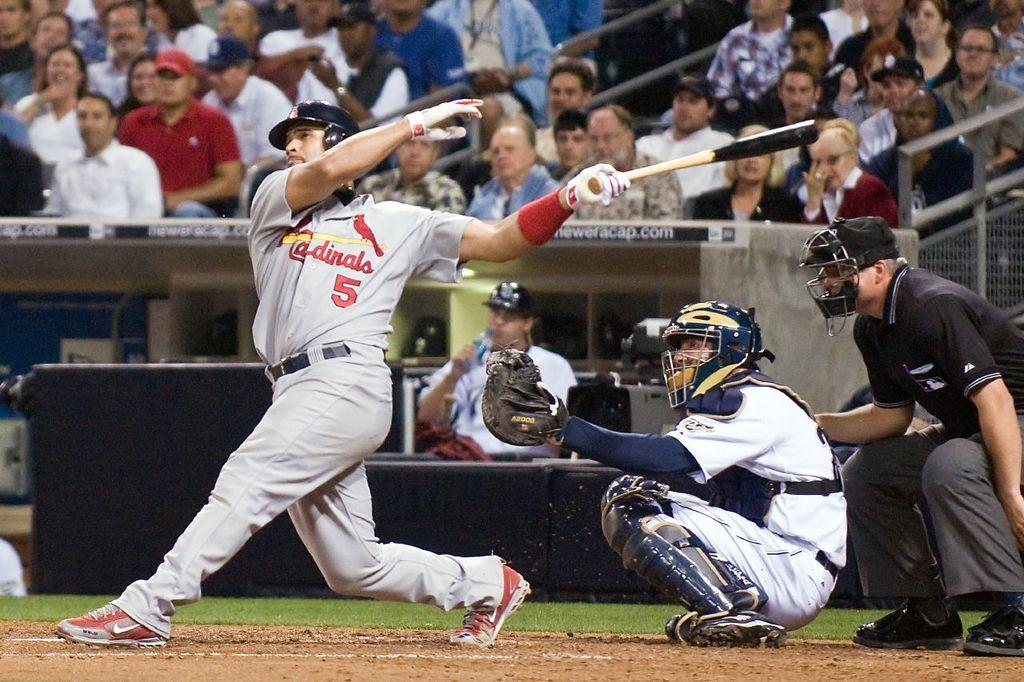<image>
Create a compact narrative representing the image presented. A player with a 5 on his uniform is batting. 